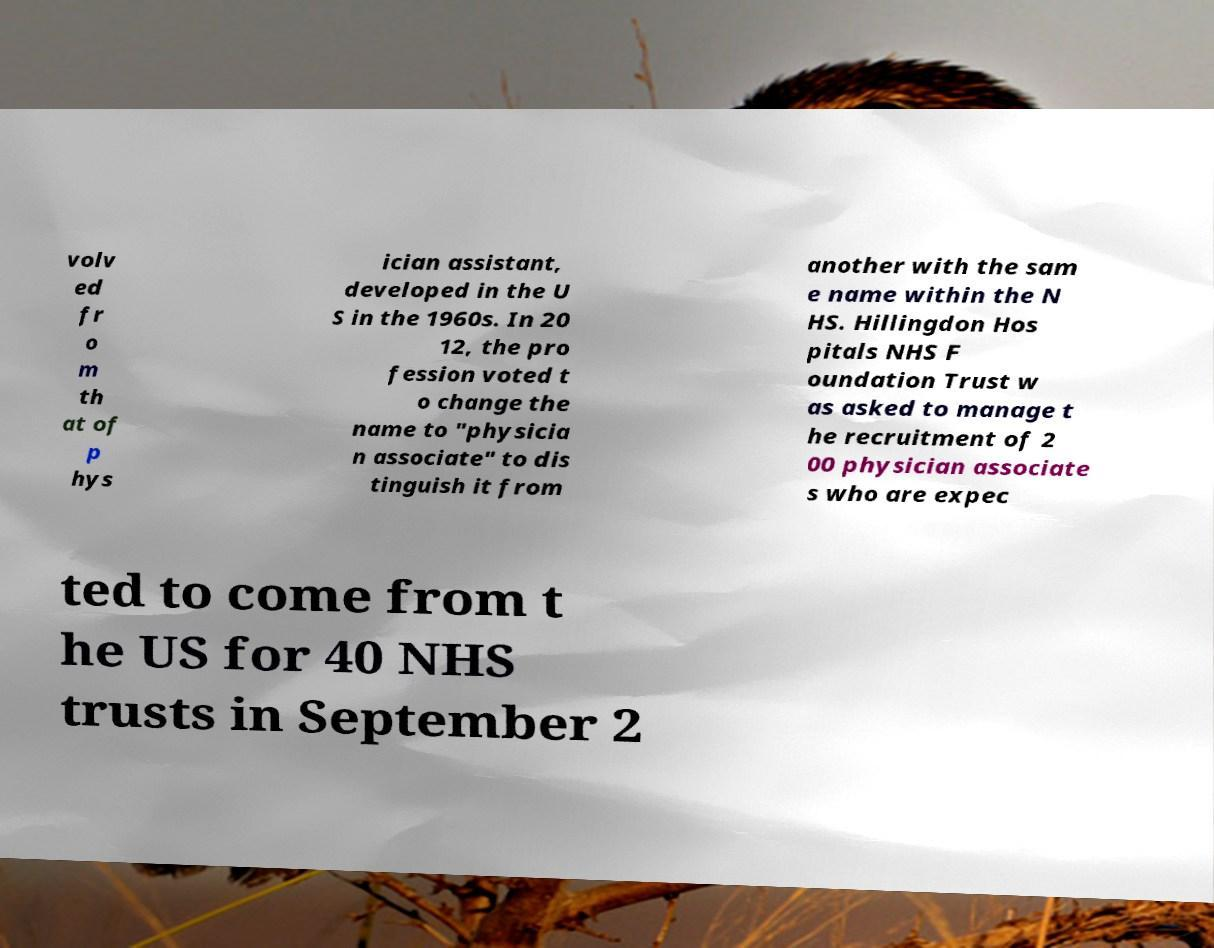Please read and relay the text visible in this image. What does it say? volv ed fr o m th at of p hys ician assistant, developed in the U S in the 1960s. In 20 12, the pro fession voted t o change the name to "physicia n associate" to dis tinguish it from another with the sam e name within the N HS. Hillingdon Hos pitals NHS F oundation Trust w as asked to manage t he recruitment of 2 00 physician associate s who are expec ted to come from t he US for 40 NHS trusts in September 2 